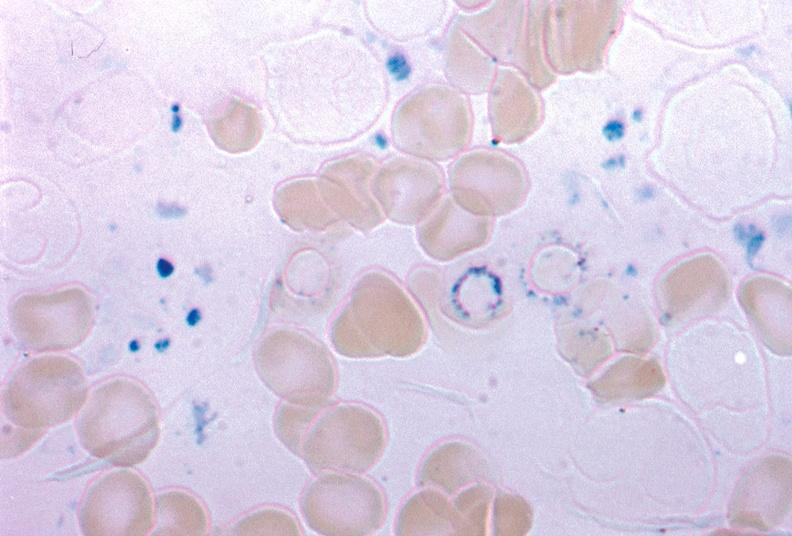s hematologic present?
Answer the question using a single word or phrase. Yes 